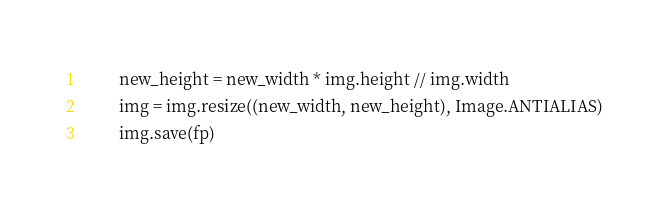Convert code to text. <code><loc_0><loc_0><loc_500><loc_500><_Python_>        new_height = new_width * img.height // img.width
        img = img.resize((new_width, new_height), Image.ANTIALIAS)
        img.save(fp)</code> 